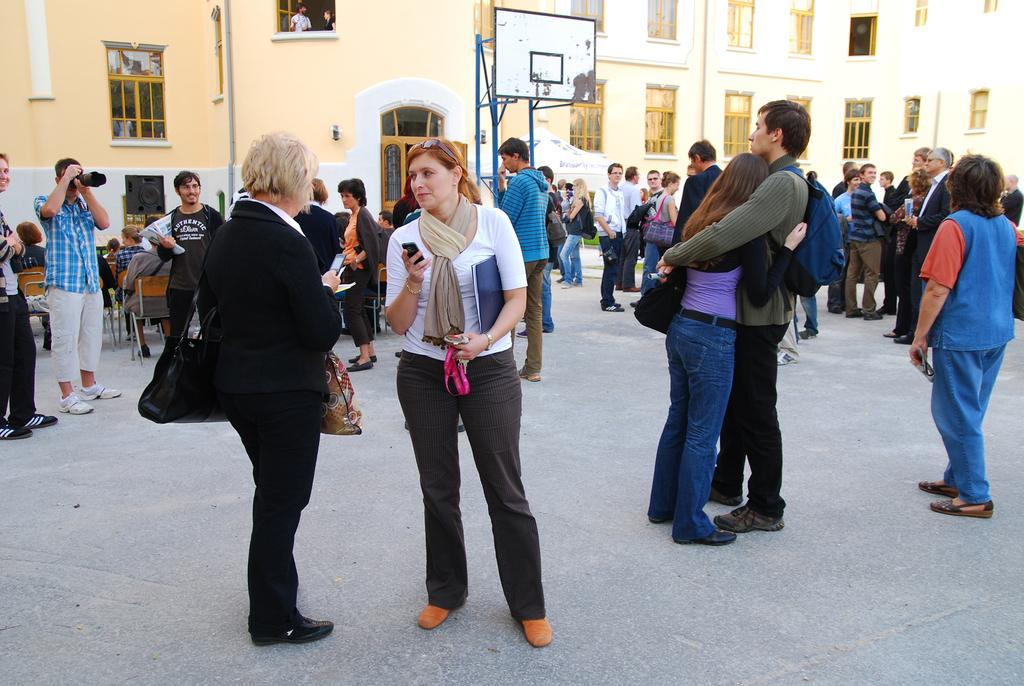How many people are in the image? There is a group of people in the image, but the exact number cannot be determined from the provided facts. What are the people in the image doing? Some people are standing on the floor, and some are sitting on chairs. What is the board in the image used for? The purpose of the board in the image cannot be determined from the provided facts. What are the bags in the image used for? The purpose of the bags in the image cannot be determined from the provided facts. What is the camera in the image used for? The purpose of the camera in the image cannot be determined from the provided facts. What can be seen through the windows of the building in the image? The view through the windows of the building in the image cannot be determined from the provided facts. What other objects are present in the image? There are other objects in the image, but their specific nature cannot be determined from the provided facts. What type of tree can be seen growing through the vessel in the image? There is no tree or vessel present in the image. 